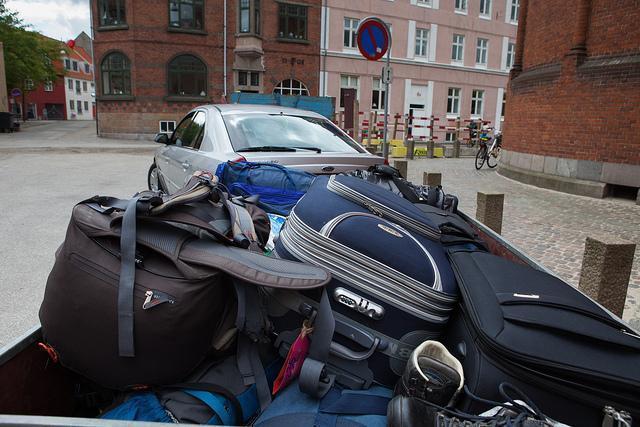What type window is the person who is photographing this luggage looking here?
Pick the correct solution from the four options below to address the question.
Options: Side, windshield, rear, front. Rear. 